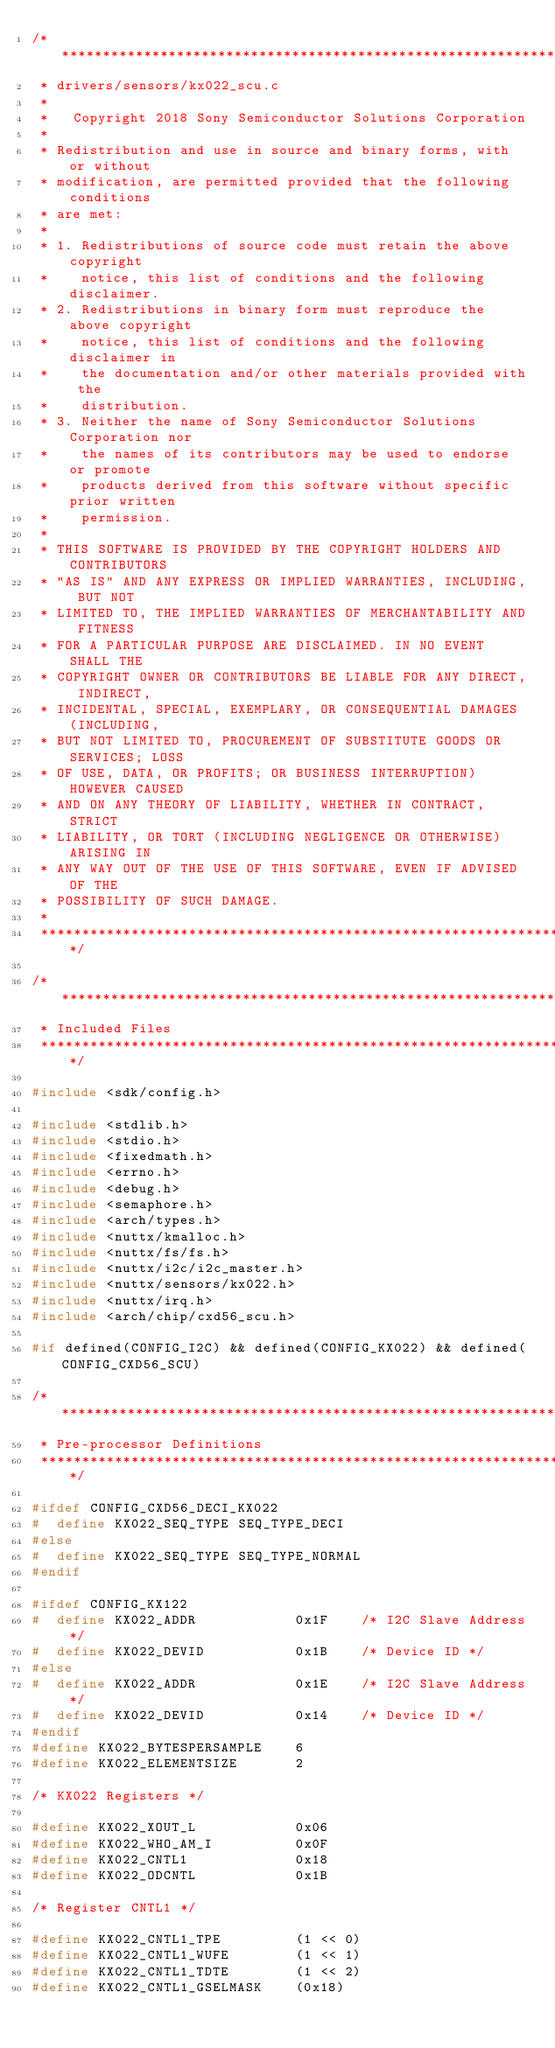<code> <loc_0><loc_0><loc_500><loc_500><_C_>/****************************************************************************
 * drivers/sensors/kx022_scu.c
 *
 *   Copyright 2018 Sony Semiconductor Solutions Corporation
 *
 * Redistribution and use in source and binary forms, with or without
 * modification, are permitted provided that the following conditions
 * are met:
 *
 * 1. Redistributions of source code must retain the above copyright
 *    notice, this list of conditions and the following disclaimer.
 * 2. Redistributions in binary form must reproduce the above copyright
 *    notice, this list of conditions and the following disclaimer in
 *    the documentation and/or other materials provided with the
 *    distribution.
 * 3. Neither the name of Sony Semiconductor Solutions Corporation nor
 *    the names of its contributors may be used to endorse or promote
 *    products derived from this software without specific prior written
 *    permission.
 *
 * THIS SOFTWARE IS PROVIDED BY THE COPYRIGHT HOLDERS AND CONTRIBUTORS
 * "AS IS" AND ANY EXPRESS OR IMPLIED WARRANTIES, INCLUDING, BUT NOT
 * LIMITED TO, THE IMPLIED WARRANTIES OF MERCHANTABILITY AND FITNESS
 * FOR A PARTICULAR PURPOSE ARE DISCLAIMED. IN NO EVENT SHALL THE
 * COPYRIGHT OWNER OR CONTRIBUTORS BE LIABLE FOR ANY DIRECT, INDIRECT,
 * INCIDENTAL, SPECIAL, EXEMPLARY, OR CONSEQUENTIAL DAMAGES (INCLUDING,
 * BUT NOT LIMITED TO, PROCUREMENT OF SUBSTITUTE GOODS OR SERVICES; LOSS
 * OF USE, DATA, OR PROFITS; OR BUSINESS INTERRUPTION) HOWEVER CAUSED
 * AND ON ANY THEORY OF LIABILITY, WHETHER IN CONTRACT, STRICT
 * LIABILITY, OR TORT (INCLUDING NEGLIGENCE OR OTHERWISE) ARISING IN
 * ANY WAY OUT OF THE USE OF THIS SOFTWARE, EVEN IF ADVISED OF THE
 * POSSIBILITY OF SUCH DAMAGE.
 *
 ****************************************************************************/

/****************************************************************************
 * Included Files
 ****************************************************************************/

#include <sdk/config.h>

#include <stdlib.h>
#include <stdio.h>
#include <fixedmath.h>
#include <errno.h>
#include <debug.h>
#include <semaphore.h>
#include <arch/types.h>
#include <nuttx/kmalloc.h>
#include <nuttx/fs/fs.h>
#include <nuttx/i2c/i2c_master.h>
#include <nuttx/sensors/kx022.h>
#include <nuttx/irq.h>
#include <arch/chip/cxd56_scu.h>

#if defined(CONFIG_I2C) && defined(CONFIG_KX022) && defined(CONFIG_CXD56_SCU)

/****************************************************************************
 * Pre-processor Definitions
 ****************************************************************************/

#ifdef CONFIG_CXD56_DECI_KX022
#  define KX022_SEQ_TYPE SEQ_TYPE_DECI
#else
#  define KX022_SEQ_TYPE SEQ_TYPE_NORMAL
#endif

#ifdef CONFIG_KX122
#  define KX022_ADDR            0x1F    /* I2C Slave Address */
#  define KX022_DEVID           0x1B    /* Device ID */
#else
#  define KX022_ADDR            0x1E    /* I2C Slave Address */
#  define KX022_DEVID           0x14    /* Device ID */
#endif
#define KX022_BYTESPERSAMPLE    6
#define KX022_ELEMENTSIZE       2

/* KX022 Registers */

#define KX022_XOUT_L            0x06
#define KX022_WHO_AM_I          0x0F
#define KX022_CNTL1             0x18
#define KX022_ODCNTL            0x1B

/* Register CNTL1 */

#define KX022_CNTL1_TPE         (1 << 0)
#define KX022_CNTL1_WUFE        (1 << 1)
#define KX022_CNTL1_TDTE        (1 << 2)
#define KX022_CNTL1_GSELMASK    (0x18)</code> 